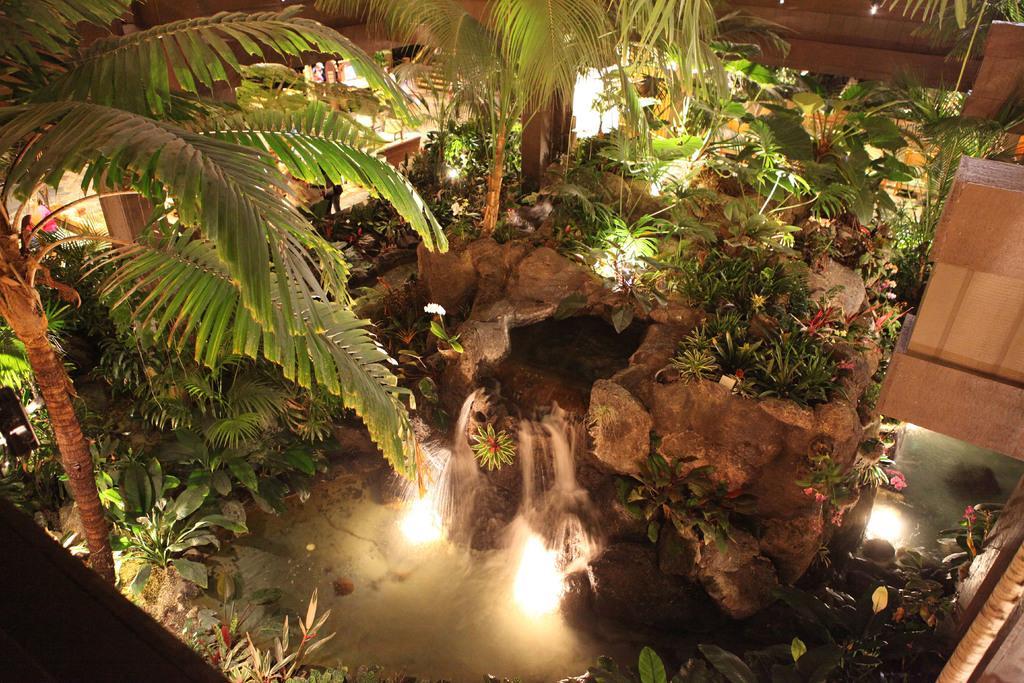How would you summarize this image in a sentence or two? There are trees, plants, water, lights and waterfall. 